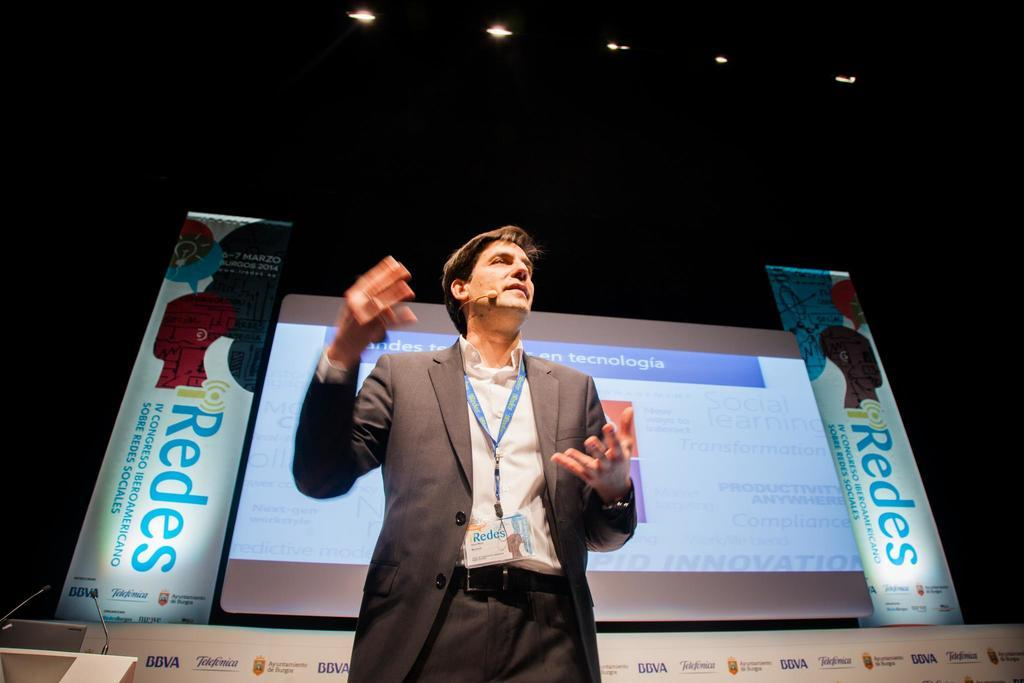What is the main subject of the image? There is a person standing in the image. What can be seen in the background of the image? There is a big screen in the image. Are there any additional elements on the sides of the screen? Yes, there are two banners on the sides of the screen. What type of bird can be seen flying across the screen in the image? There is no bird visible in the image; it only features a person, a big screen, and two banners. Can you tell me how many planes are flying in the night sky in the image? There is no mention of planes or a night sky in the image; it only features a person, a big screen, and two banners. 